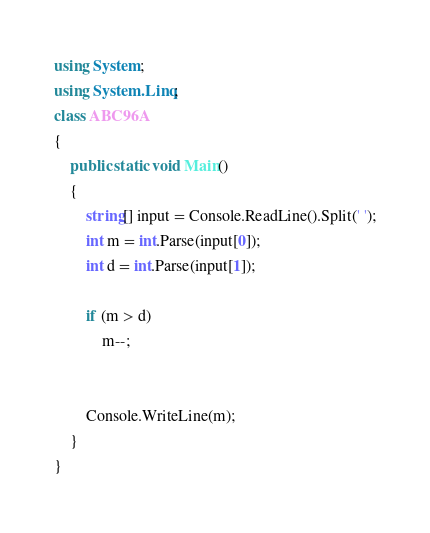<code> <loc_0><loc_0><loc_500><loc_500><_C#_>using System;
using System.Linq;
class ABC96A
{
    public static void Main()
    {
        string[] input = Console.ReadLine().Split(' ');
        int m = int.Parse(input[0]);
        int d = int.Parse(input[1]);

        if (m > d)
            m--;


        Console.WriteLine(m);
    }
}</code> 